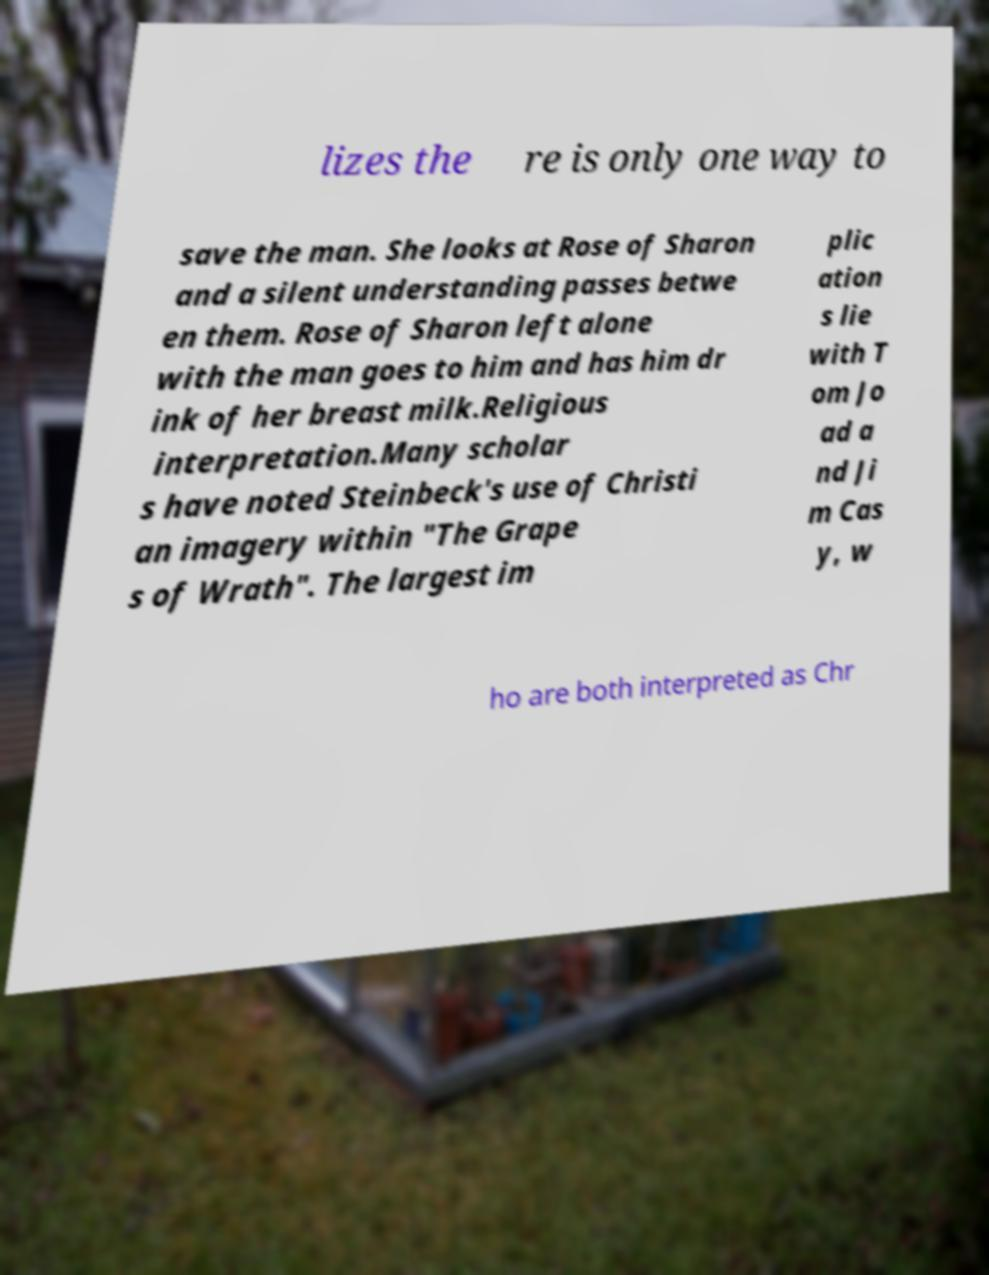Please read and relay the text visible in this image. What does it say? lizes the re is only one way to save the man. She looks at Rose of Sharon and a silent understanding passes betwe en them. Rose of Sharon left alone with the man goes to him and has him dr ink of her breast milk.Religious interpretation.Many scholar s have noted Steinbeck's use of Christi an imagery within "The Grape s of Wrath". The largest im plic ation s lie with T om Jo ad a nd Ji m Cas y, w ho are both interpreted as Chr 